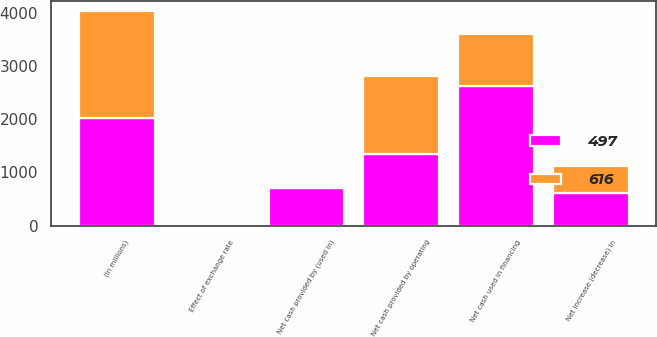Convert chart to OTSL. <chart><loc_0><loc_0><loc_500><loc_500><stacked_bar_chart><ecel><fcel>(In millions)<fcel>Net cash provided by operating<fcel>Net cash provided by (used in)<fcel>Net cash used in financing<fcel>Effect of exchange rate<fcel>Net increase (decrease) in<nl><fcel>497<fcel>2019<fcel>1341<fcel>704<fcel>2631<fcel>30<fcel>616<nl><fcel>616<fcel>2018<fcel>1478<fcel>21<fcel>986<fcel>26<fcel>497<nl></chart> 